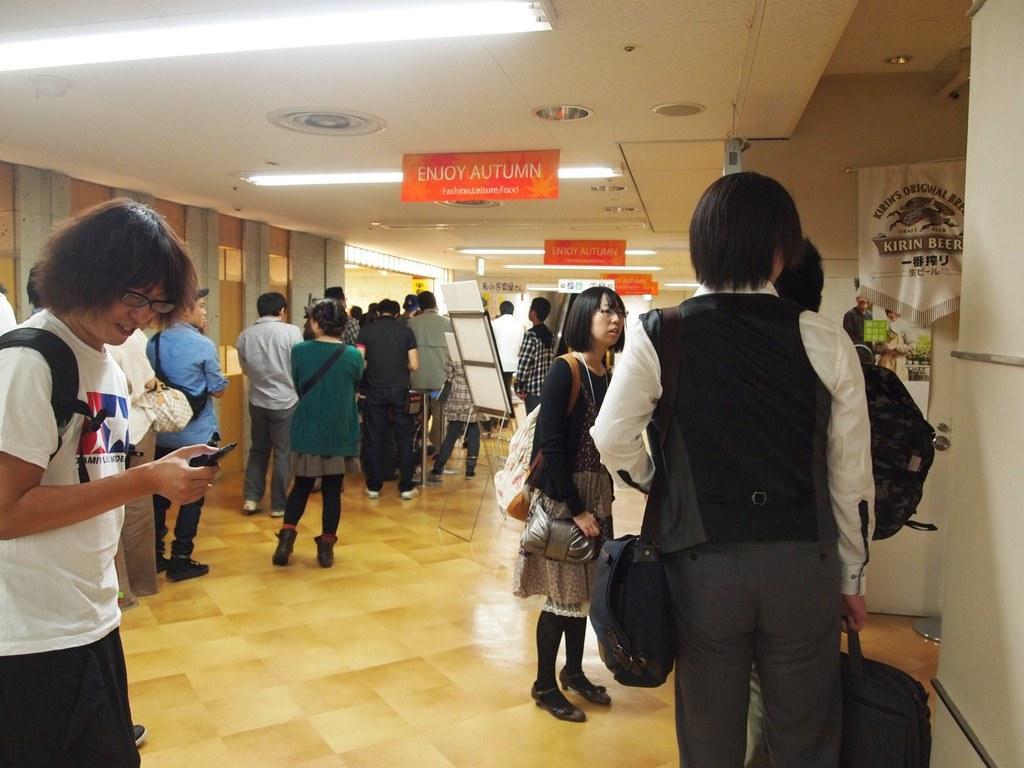Describe this image in one or two sentences. On the left side of the image we can see one person is standing and he is smiling. And we can see he is holding some object and he is wearing a backpack and glasses. On the right side of the image, we can see one pillar and people are standing and they are holding some objects. In the background there is a wall, lights, banners, one stand, one board, few people are standing, few people are holding some objects and a few other objects. On the banners, we can see some text. 